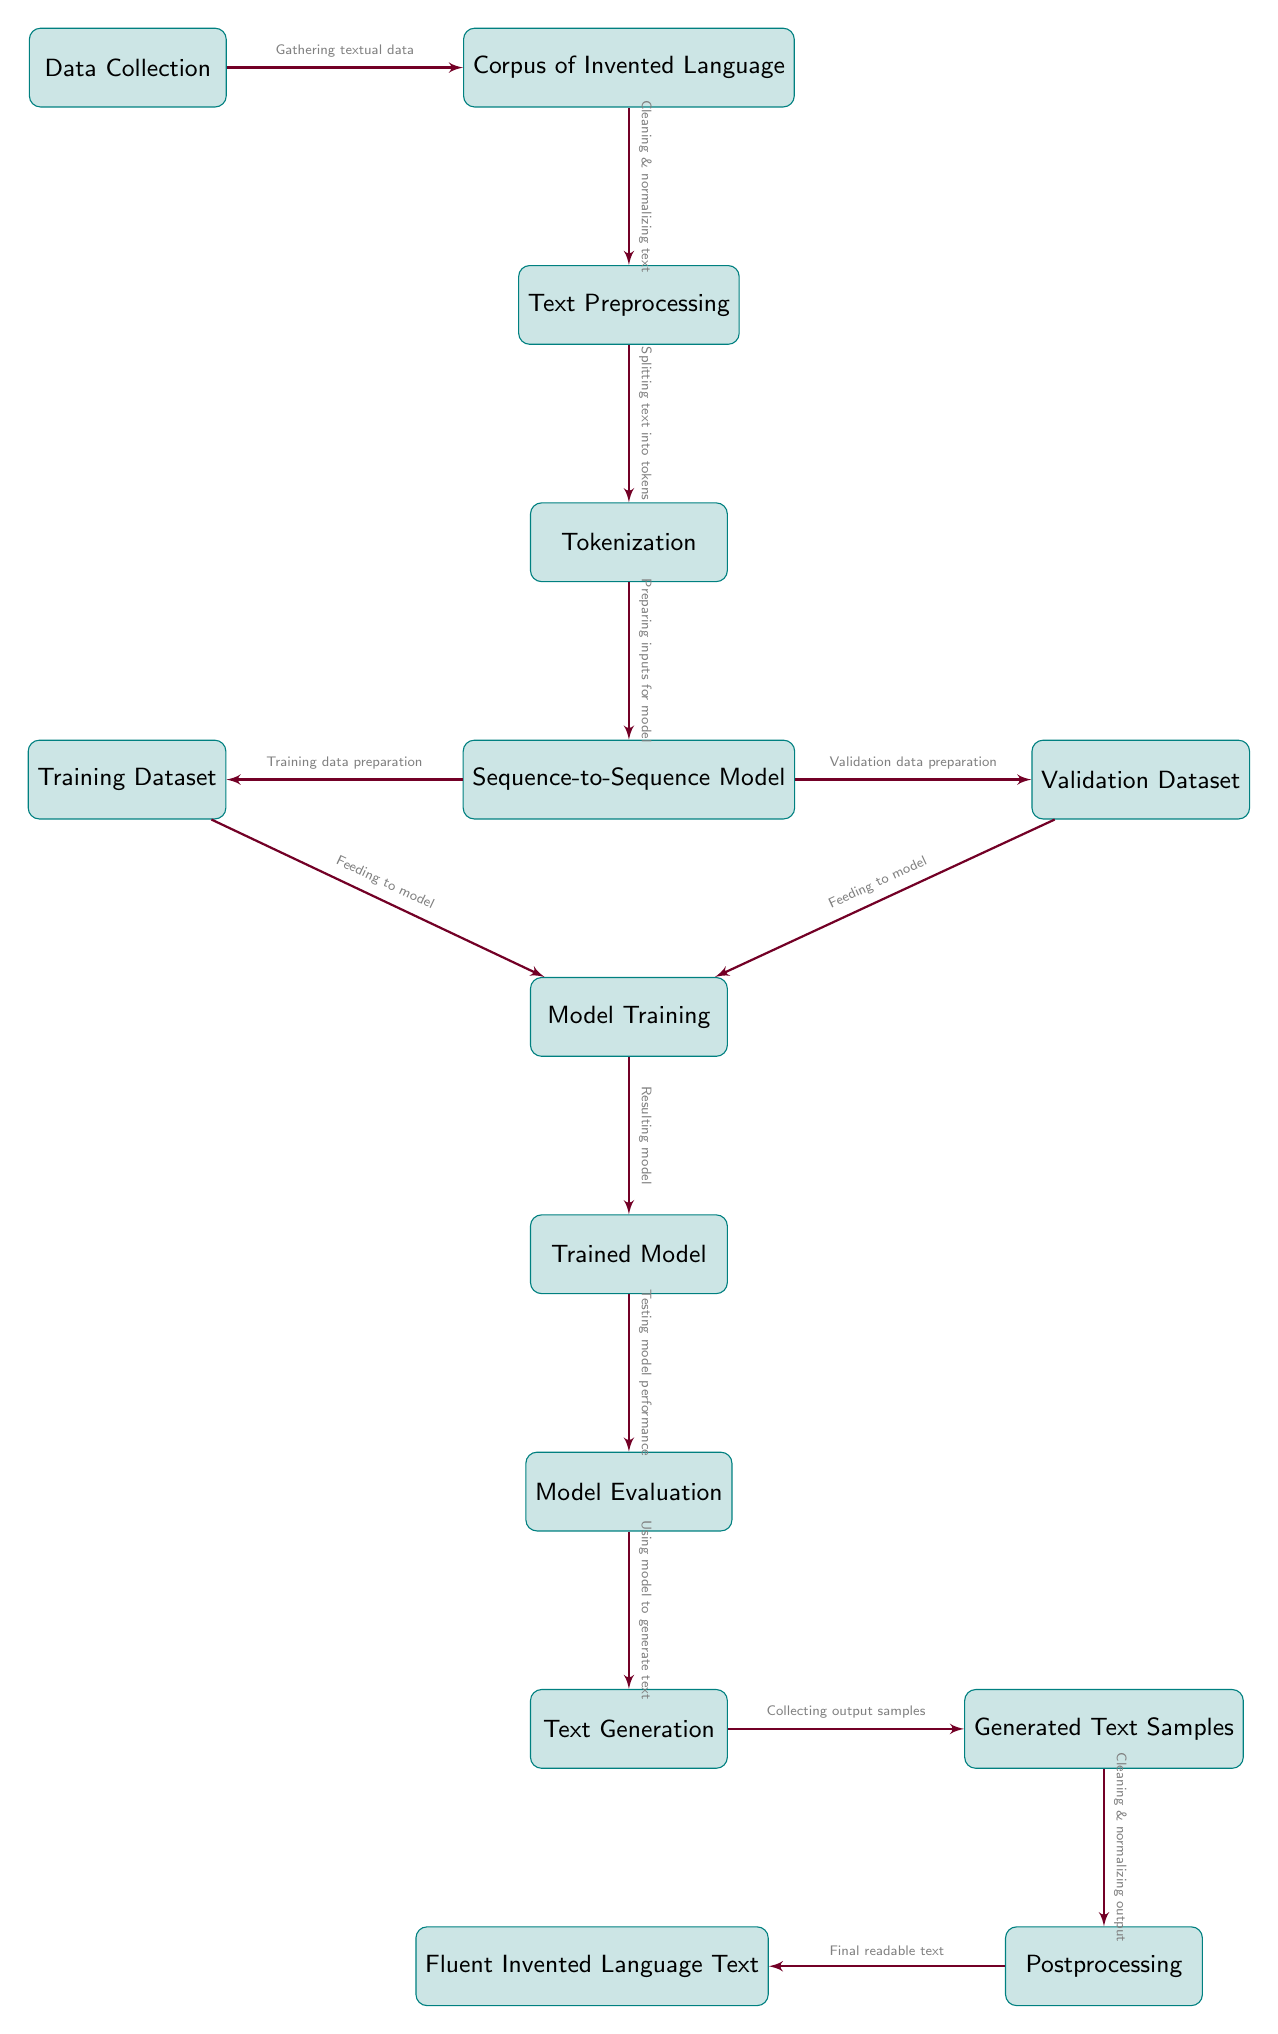What is the first step in the pipeline? The first step in the diagram is "Data Collection," which initiates the process of creating a predictive text model for invented languages.
Answer: Data Collection How many nodes represent processes involved in text generation? There are eleven distinct nodes in the diagram that represent processes involved in generating text for the invented language.
Answer: Eleven What type of data is cleaned and normalized in the second step? The second step involves cleaning and normalizing the "Corpus of Invented Language," which is the textual data collected in the first step.
Answer: Corpus of Invented Language What is generated after the "Model Evaluation" process? The next node after "Model Evaluation" is "Text Generation," where the model is utilized to generate text based on its evaluations and training.
Answer: Text Generation Which node gathers textual data? The node that gathers textual data is "Data Collection," as it represents the initiation point for input data required for training the model.
Answer: Data Collection What prepares the inputs for the sequence-to-sequence model? The "Tokenization" node prepares the inputs for the sequence-to-sequence model, converting the cleaned text into a suitable format for model ingestion.
Answer: Tokenization What step follows the "Training Dataset" preparation? The next step after preparing the "Training Dataset" is "Model Training," where the model is trained using the prepared datasets.
Answer: Model Training Which node provides the "Final readable text"? The "Postprocessing" node leads to the "Fluent Invented Language Text," producing the final form of text after all previous processes.
Answer: Postprocessing What is done with the generated text samples? The generated samples go through "Postprocessing," where they are cleaned and normalized before presenting the final readable text.
Answer: Postprocessing How many distinct datasets are specified in the model training phase? Two distinct datasets are specified in the model training phase: the "Training Dataset" and the "Validation Dataset," which are both fed into the model during training.
Answer: Two 